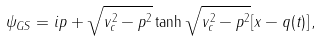<formula> <loc_0><loc_0><loc_500><loc_500>\psi _ { G S } = i p + \sqrt { v _ { c } ^ { 2 } - p ^ { 2 } } \tanh \sqrt { v _ { c } ^ { 2 } - p ^ { 2 } } [ x - q ( t ) ] \, ,</formula> 